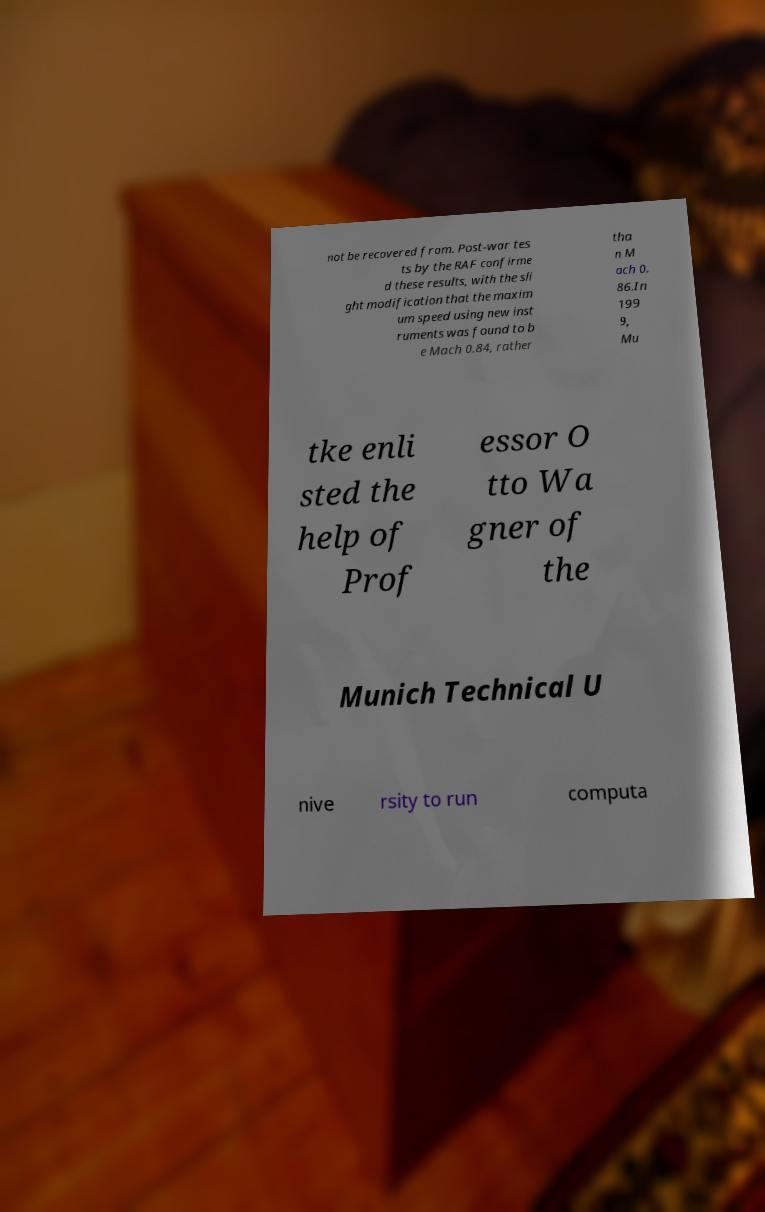I need the written content from this picture converted into text. Can you do that? not be recovered from. Post-war tes ts by the RAF confirme d these results, with the sli ght modification that the maxim um speed using new inst ruments was found to b e Mach 0.84, rather tha n M ach 0. 86.In 199 9, Mu tke enli sted the help of Prof essor O tto Wa gner of the Munich Technical U nive rsity to run computa 